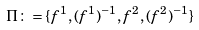Convert formula to latex. <formula><loc_0><loc_0><loc_500><loc_500>\Pi \colon = \{ f ^ { 1 } , ( f ^ { 1 } ) ^ { - 1 } , f ^ { 2 } , ( f ^ { 2 } ) ^ { - 1 } \}</formula> 